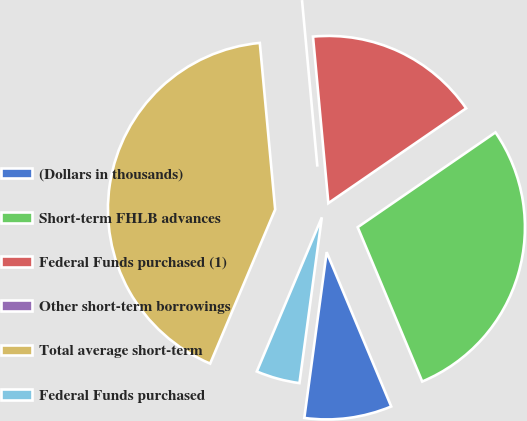<chart> <loc_0><loc_0><loc_500><loc_500><pie_chart><fcel>(Dollars in thousands)<fcel>Short-term FHLB advances<fcel>Federal Funds purchased (1)<fcel>Other short-term borrowings<fcel>Total average short-term<fcel>Federal Funds purchased<nl><fcel>8.44%<fcel>28.29%<fcel>16.87%<fcel>0.0%<fcel>42.18%<fcel>4.22%<nl></chart> 